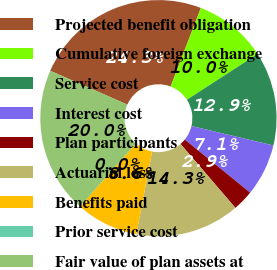Convert chart to OTSL. <chart><loc_0><loc_0><loc_500><loc_500><pie_chart><fcel>Projected benefit obligation<fcel>Cumulative foreign exchange<fcel>Service cost<fcel>Interest cost<fcel>Plan participants<fcel>Actuarial loss<fcel>Benefits paid<fcel>Prior service cost<fcel>Fair value of plan assets at<nl><fcel>24.28%<fcel>10.0%<fcel>12.86%<fcel>7.14%<fcel>2.86%<fcel>14.28%<fcel>8.57%<fcel>0.0%<fcel>20.0%<nl></chart> 